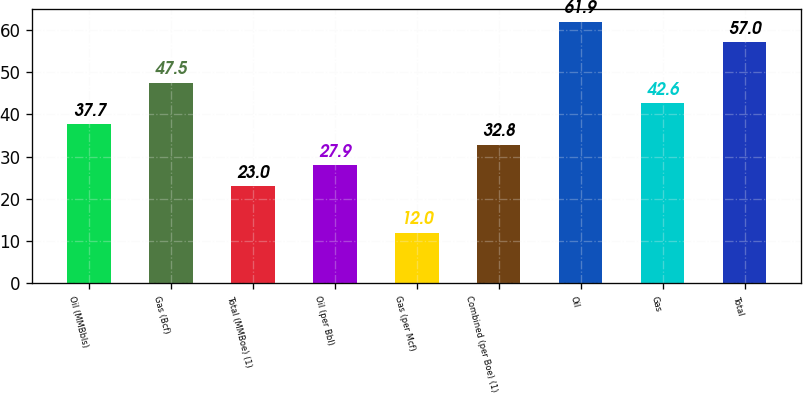Convert chart. <chart><loc_0><loc_0><loc_500><loc_500><bar_chart><fcel>Oil (MMBbls)<fcel>Gas (Bcf)<fcel>Total (MMBoe) (1)<fcel>Oil (per Bbl)<fcel>Gas (per Mcf)<fcel>Combined (per Boe) (1)<fcel>Oil<fcel>Gas<fcel>Total<nl><fcel>37.7<fcel>47.5<fcel>23<fcel>27.9<fcel>12<fcel>32.8<fcel>61.9<fcel>42.6<fcel>57<nl></chart> 